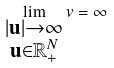<formula> <loc_0><loc_0><loc_500><loc_500>\lim _ { \substack { | \mathbf u | \to \infty \\ \mathbf u \in \mathbb { R } ^ { N } _ { + } } } v = \infty</formula> 